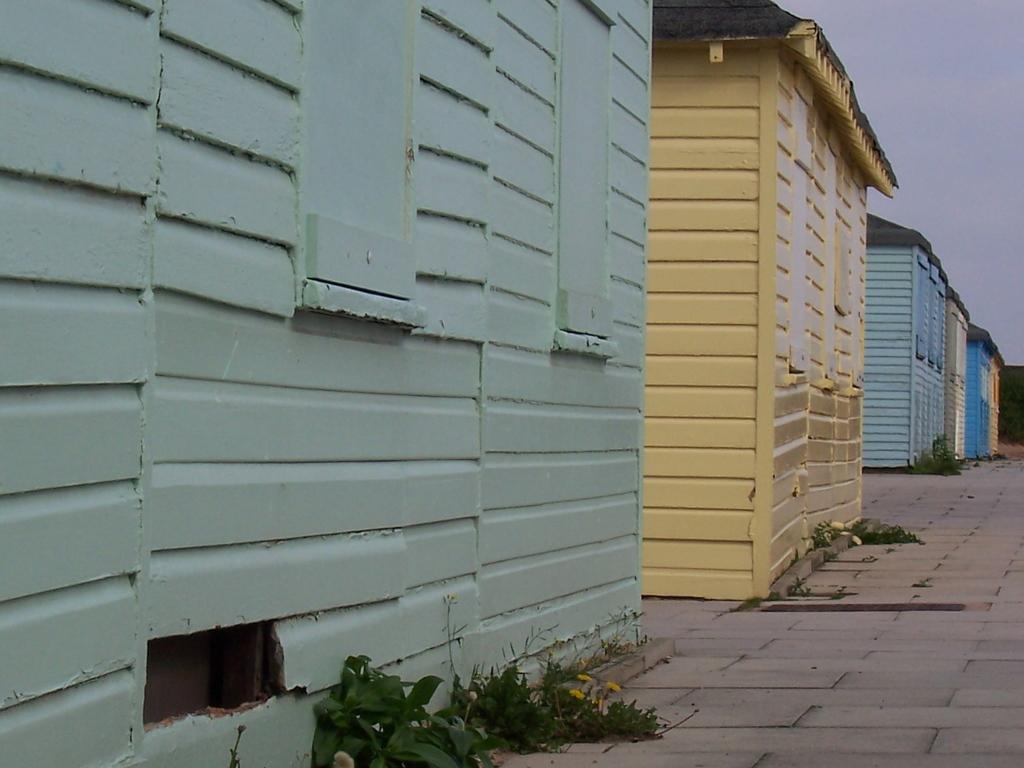Please provide a concise description of this image. In this image we can see there are wooden houses, in front of the houses there are grass on the path. In the background there is the sky. 